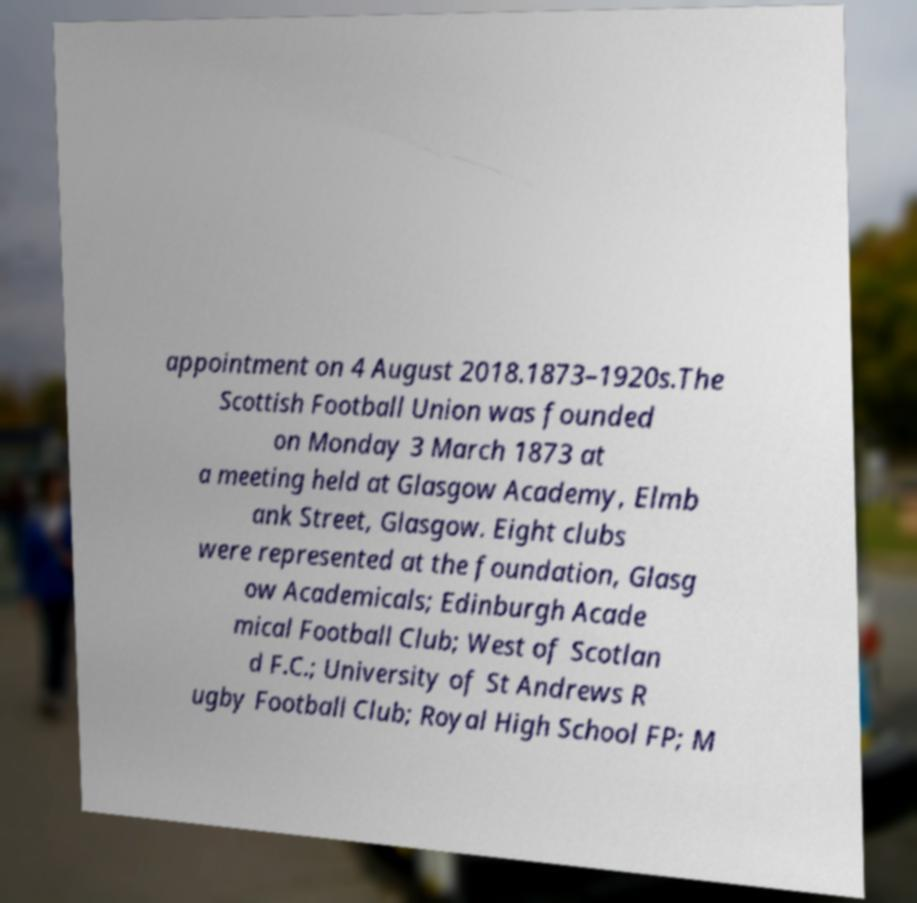Can you accurately transcribe the text from the provided image for me? appointment on 4 August 2018.1873–1920s.The Scottish Football Union was founded on Monday 3 March 1873 at a meeting held at Glasgow Academy, Elmb ank Street, Glasgow. Eight clubs were represented at the foundation, Glasg ow Academicals; Edinburgh Acade mical Football Club; West of Scotlan d F.C.; University of St Andrews R ugby Football Club; Royal High School FP; M 